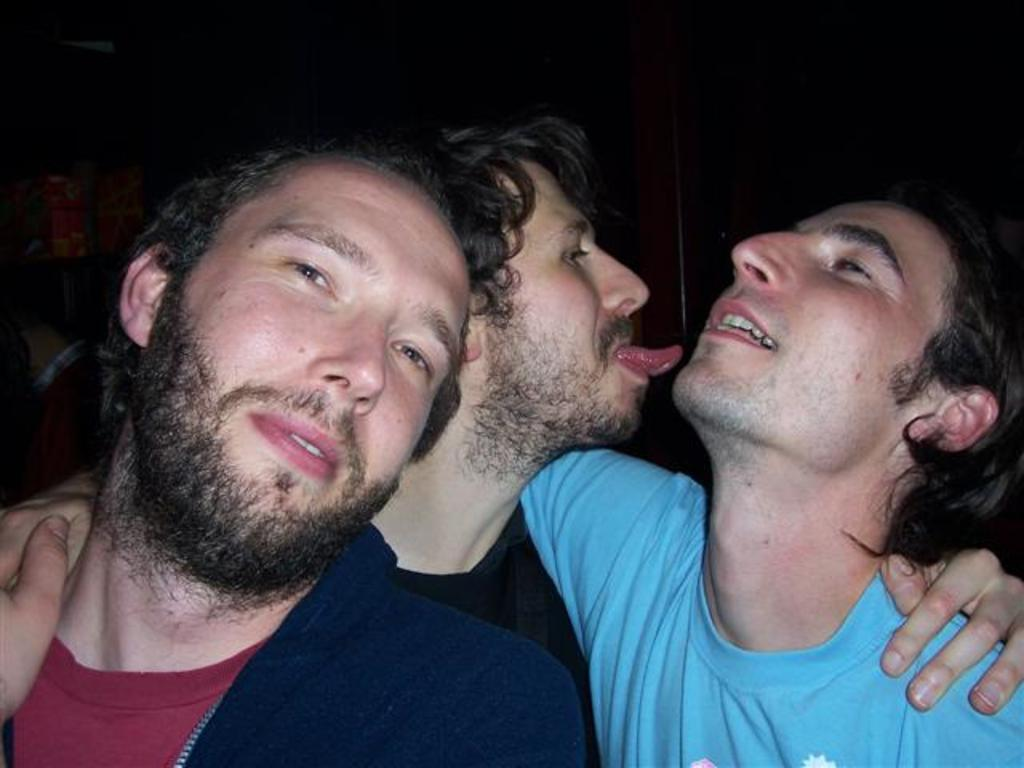How many people are in the image? There are three men in the image. What is the color of the background in the image? The background of the image is dark. Can you see a bridge in the image? There is no bridge present in the image. What direction are the men blowing in the image? The men are not blowing in any direction in the image, as there is no indication of blowing or wind. 